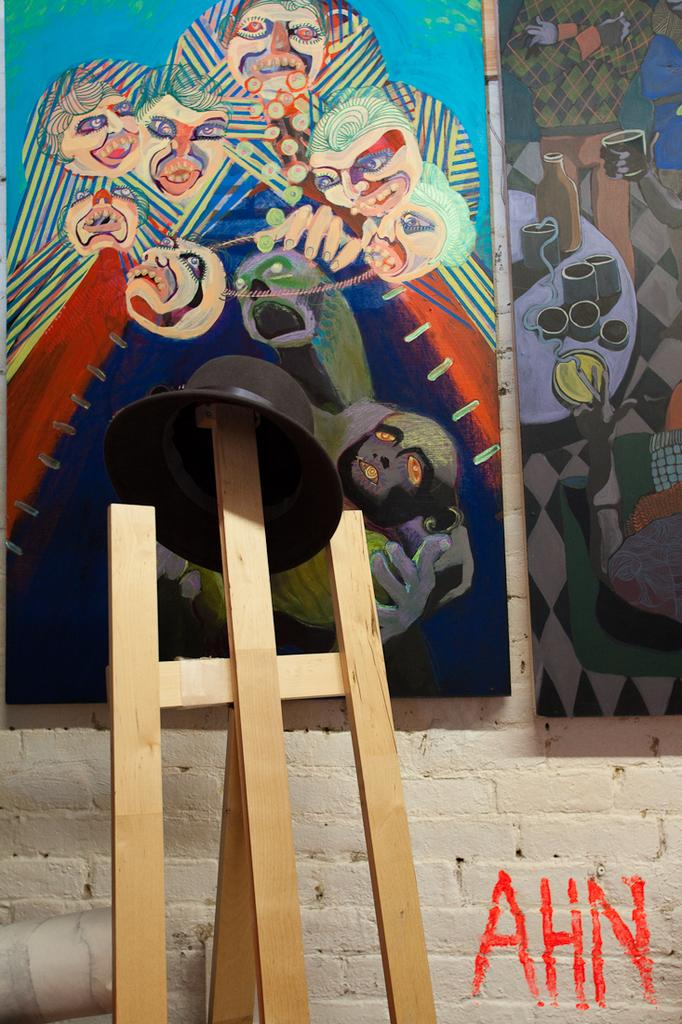What is the main subject in the center of the image? There is a hat in the center of the image. How is the hat supported in the image? The hat is on wooden sticks. What can be seen in the background of the image? There are posters on the wall in the background of the image. How many bottles are placed on the hat in the image? There are no bottles present on the hat in the image. 